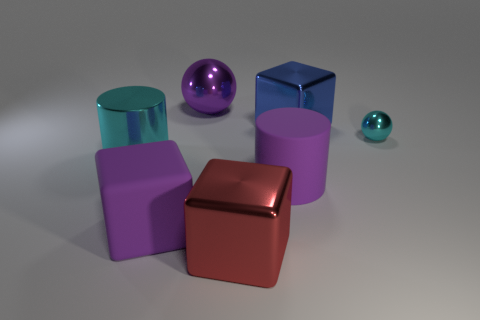What number of matte things are either cyan spheres or purple spheres?
Your answer should be very brief. 0. What shape is the blue object that is the same size as the red block?
Provide a succinct answer. Cube. How many things are either purple matte things that are on the right side of the red thing or big shiny objects that are behind the purple matte cylinder?
Keep it short and to the point. 4. There is a blue thing that is the same size as the matte cube; what is it made of?
Offer a terse response. Metal. What number of other objects are there of the same material as the small thing?
Make the answer very short. 4. Are there the same number of blue shiny cubes in front of the tiny cyan metallic object and large purple objects behind the big rubber cube?
Keep it short and to the point. No. What number of red objects are either metallic cubes or small shiny balls?
Your answer should be very brief. 1. Do the big matte cube and the big cylinder that is on the right side of the big purple metal thing have the same color?
Offer a very short reply. Yes. How many other things are there of the same color as the large rubber cube?
Provide a succinct answer. 2. Are there fewer red metal objects than purple matte things?
Make the answer very short. Yes. 